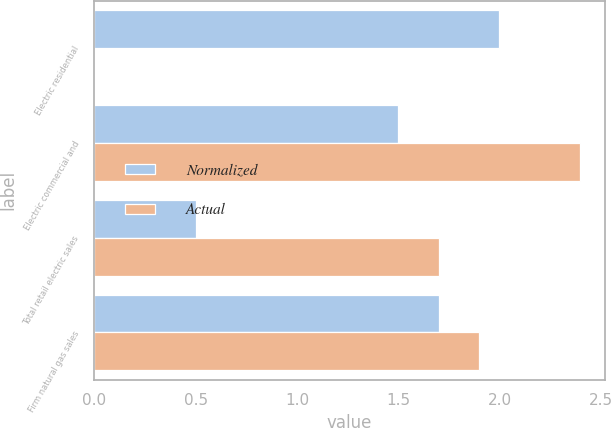Convert chart. <chart><loc_0><loc_0><loc_500><loc_500><stacked_bar_chart><ecel><fcel>Electric residential<fcel>Electric commercial and<fcel>Total retail electric sales<fcel>Firm natural gas sales<nl><fcel>Normalized<fcel>2<fcel>1.5<fcel>0.5<fcel>1.7<nl><fcel>Actual<fcel>0<fcel>2.4<fcel>1.7<fcel>1.9<nl></chart> 